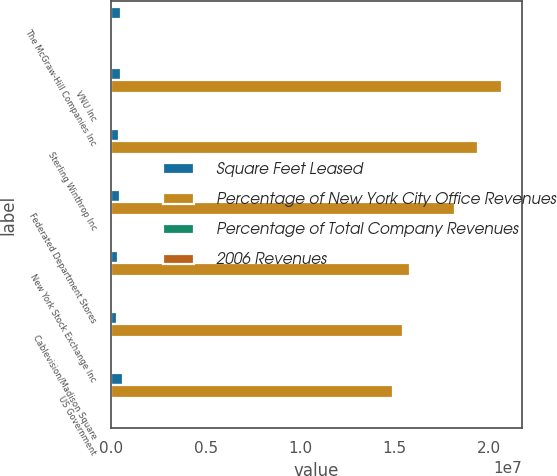Convert chart. <chart><loc_0><loc_0><loc_500><loc_500><stacked_bar_chart><ecel><fcel>The McGraw-Hill Companies Inc<fcel>VNU Inc<fcel>Sterling Winthrop Inc<fcel>Federated Department Stores<fcel>New York Stock Exchange Inc<fcel>Cablevision/Madison Square<fcel>US Government<nl><fcel>Square Feet Leased<fcel>536000<fcel>515000<fcel>429000<fcel>467000<fcel>348000<fcel>310000<fcel>639000<nl><fcel>Percentage of New York City Office Revenues<fcel>3.3<fcel>2.0695e+07<fcel>1.9398e+07<fcel>1.8192e+07<fcel>1.5822e+07<fcel>1.5416e+07<fcel>1.4906e+07<nl><fcel>Percentage of Total Company Revenues<fcel>3.3<fcel>3<fcel>2.8<fcel>2.7<fcel>2.3<fcel>2.3<fcel>2.2<nl><fcel>2006 Revenues<fcel>0.8<fcel>0.8<fcel>0.7<fcel>0.7<fcel>0.6<fcel>0.6<fcel>0.5<nl></chart> 